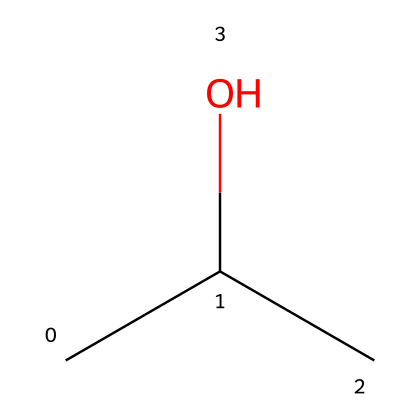What is the name of this chemical? The provided SMILES representation "CC(C)O" corresponds to isopropyl alcohol, which is a common name for the compound. The core structure contains a propanol group with the hydroxyl (OH) functional group indicating it is an alcohol.
Answer: isopropyl alcohol How many carbon atoms are in this chemical? Analyzing the SMILES "CC(C)O", we find three carbon atoms (C), as represented by "CC" (two carbon atoms) and "(C)" (one additional carbon atom branching from the central carbon).
Answer: 3 What functional group is present in isopropyl alcohol? The presence of the "O" in the SMILES indicates a hydroxyl (-OH) functional group, which is characteristic of alcohols, specifically in this case, isopropyl alcohol.
Answer: hydroxyl Is isopropyl alcohol flammable? Given that isopropyl alcohol is classified as a flammable liquid due to its low flash point, safety data, and handling protocols for injury treatments highlight this characteristic, confirming its classification.
Answer: yes Which type of compound is isopropyl alcohol? The -OH group indicates it is an alcohol, while the carbon skeleton signifies that it falls under the category of organic compounds. Thus, it is specifically an alcohol.
Answer: alcohol What is the molecular formula for isopropyl alcohol? From the structure represented by the SMILES "CC(C)O", we can deduce the molecular formula by counting the atoms: three carbon atoms (C), eight hydrogen atoms (H), and one oxygen atom (O); thus, the formula is C3H8O.
Answer: C3H8O What proportion of atoms in isopropyl alcohol are oxygen? In the molecule C3H8O, there are 3 carbon atoms, 8 hydrogen atoms, and 1 oxygen atom, making a total of 12 atoms; therefore, the proportion of oxygen atoms is 1 out of 12.
Answer: 1/12 